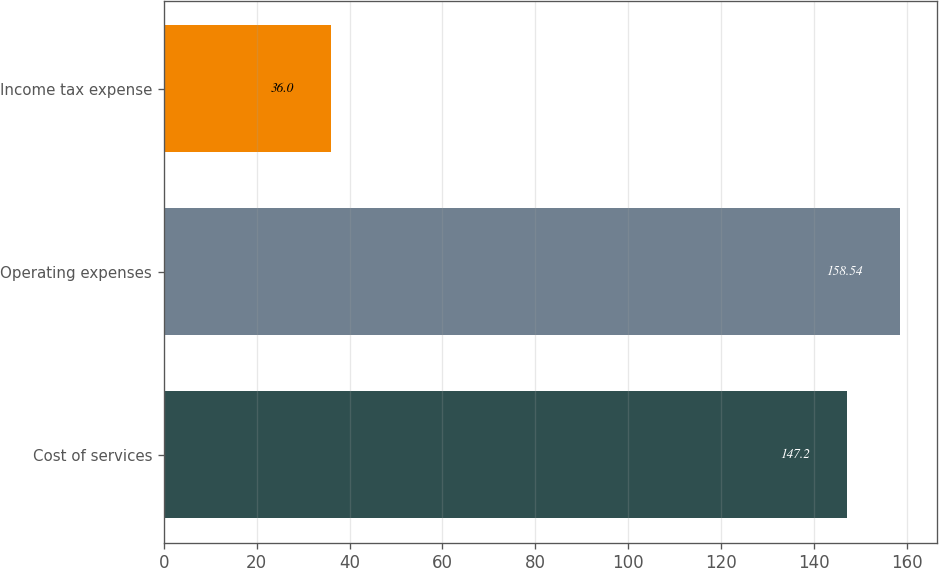Convert chart to OTSL. <chart><loc_0><loc_0><loc_500><loc_500><bar_chart><fcel>Cost of services<fcel>Operating expenses<fcel>Income tax expense<nl><fcel>147.2<fcel>158.54<fcel>36<nl></chart> 